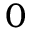<formula> <loc_0><loc_0><loc_500><loc_500>0</formula> 